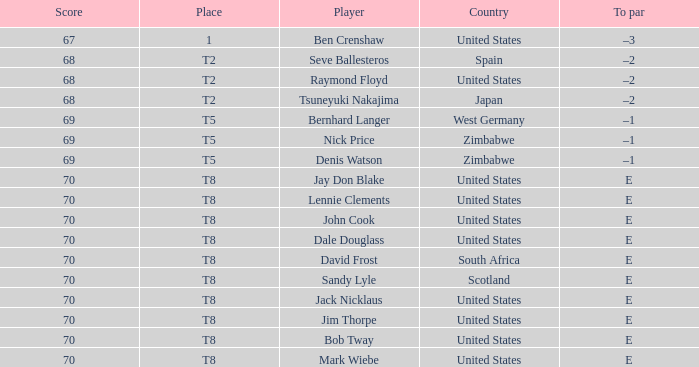What player has The United States as the country, with t2 as the place? Raymond Floyd. 